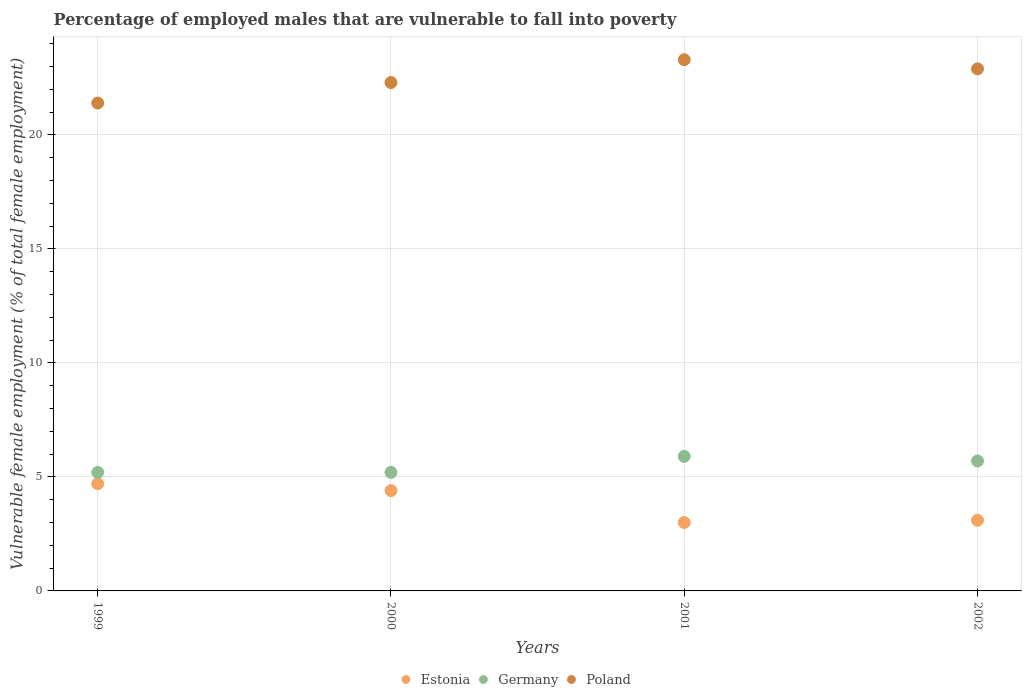What is the percentage of employed males who are vulnerable to fall into poverty in Poland in 2001?
Give a very brief answer. 23.3. Across all years, what is the maximum percentage of employed males who are vulnerable to fall into poverty in Germany?
Your answer should be very brief. 5.9. Across all years, what is the minimum percentage of employed males who are vulnerable to fall into poverty in Estonia?
Make the answer very short. 3. In which year was the percentage of employed males who are vulnerable to fall into poverty in Poland minimum?
Keep it short and to the point. 1999. What is the total percentage of employed males who are vulnerable to fall into poverty in Germany in the graph?
Provide a succinct answer. 22. What is the difference between the percentage of employed males who are vulnerable to fall into poverty in Germany in 1999 and that in 2000?
Make the answer very short. 0. What is the difference between the percentage of employed males who are vulnerable to fall into poverty in Estonia in 2002 and the percentage of employed males who are vulnerable to fall into poverty in Germany in 2001?
Offer a very short reply. -2.8. What is the average percentage of employed males who are vulnerable to fall into poverty in Poland per year?
Offer a very short reply. 22.47. In the year 2001, what is the difference between the percentage of employed males who are vulnerable to fall into poverty in Estonia and percentage of employed males who are vulnerable to fall into poverty in Germany?
Give a very brief answer. -2.9. In how many years, is the percentage of employed males who are vulnerable to fall into poverty in Estonia greater than 12 %?
Your response must be concise. 0. What is the ratio of the percentage of employed males who are vulnerable to fall into poverty in Estonia in 2000 to that in 2001?
Your answer should be very brief. 1.47. Is the percentage of employed males who are vulnerable to fall into poverty in Estonia in 2000 less than that in 2002?
Your response must be concise. No. What is the difference between the highest and the second highest percentage of employed males who are vulnerable to fall into poverty in Germany?
Offer a terse response. 0.2. What is the difference between the highest and the lowest percentage of employed males who are vulnerable to fall into poverty in Poland?
Ensure brevity in your answer.  1.9. In how many years, is the percentage of employed males who are vulnerable to fall into poverty in Poland greater than the average percentage of employed males who are vulnerable to fall into poverty in Poland taken over all years?
Ensure brevity in your answer.  2. Does the percentage of employed males who are vulnerable to fall into poverty in Poland monotonically increase over the years?
Provide a short and direct response. No. How many dotlines are there?
Your answer should be compact. 3. How many years are there in the graph?
Make the answer very short. 4. Are the values on the major ticks of Y-axis written in scientific E-notation?
Ensure brevity in your answer.  No. Does the graph contain any zero values?
Offer a very short reply. No. Does the graph contain grids?
Your answer should be very brief. Yes. Where does the legend appear in the graph?
Your answer should be very brief. Bottom center. How many legend labels are there?
Your answer should be very brief. 3. How are the legend labels stacked?
Your response must be concise. Horizontal. What is the title of the graph?
Your answer should be compact. Percentage of employed males that are vulnerable to fall into poverty. Does "Serbia" appear as one of the legend labels in the graph?
Provide a succinct answer. No. What is the label or title of the X-axis?
Make the answer very short. Years. What is the label or title of the Y-axis?
Offer a terse response. Vulnerable female employment (% of total female employment). What is the Vulnerable female employment (% of total female employment) in Estonia in 1999?
Give a very brief answer. 4.7. What is the Vulnerable female employment (% of total female employment) of Germany in 1999?
Ensure brevity in your answer.  5.2. What is the Vulnerable female employment (% of total female employment) in Poland in 1999?
Your answer should be very brief. 21.4. What is the Vulnerable female employment (% of total female employment) of Estonia in 2000?
Provide a succinct answer. 4.4. What is the Vulnerable female employment (% of total female employment) in Germany in 2000?
Provide a succinct answer. 5.2. What is the Vulnerable female employment (% of total female employment) in Poland in 2000?
Keep it short and to the point. 22.3. What is the Vulnerable female employment (% of total female employment) of Germany in 2001?
Provide a succinct answer. 5.9. What is the Vulnerable female employment (% of total female employment) of Poland in 2001?
Offer a very short reply. 23.3. What is the Vulnerable female employment (% of total female employment) of Estonia in 2002?
Offer a very short reply. 3.1. What is the Vulnerable female employment (% of total female employment) of Germany in 2002?
Give a very brief answer. 5.7. What is the Vulnerable female employment (% of total female employment) in Poland in 2002?
Offer a terse response. 22.9. Across all years, what is the maximum Vulnerable female employment (% of total female employment) of Estonia?
Provide a short and direct response. 4.7. Across all years, what is the maximum Vulnerable female employment (% of total female employment) of Germany?
Provide a succinct answer. 5.9. Across all years, what is the maximum Vulnerable female employment (% of total female employment) in Poland?
Provide a succinct answer. 23.3. Across all years, what is the minimum Vulnerable female employment (% of total female employment) of Germany?
Make the answer very short. 5.2. Across all years, what is the minimum Vulnerable female employment (% of total female employment) in Poland?
Ensure brevity in your answer.  21.4. What is the total Vulnerable female employment (% of total female employment) in Germany in the graph?
Your answer should be compact. 22. What is the total Vulnerable female employment (% of total female employment) of Poland in the graph?
Provide a short and direct response. 89.9. What is the difference between the Vulnerable female employment (% of total female employment) of Estonia in 1999 and that in 2000?
Provide a succinct answer. 0.3. What is the difference between the Vulnerable female employment (% of total female employment) of Germany in 1999 and that in 2000?
Your answer should be compact. 0. What is the difference between the Vulnerable female employment (% of total female employment) in Poland in 1999 and that in 2000?
Provide a succinct answer. -0.9. What is the difference between the Vulnerable female employment (% of total female employment) in Poland in 1999 and that in 2001?
Ensure brevity in your answer.  -1.9. What is the difference between the Vulnerable female employment (% of total female employment) in Poland in 1999 and that in 2002?
Keep it short and to the point. -1.5. What is the difference between the Vulnerable female employment (% of total female employment) in Estonia in 2000 and that in 2002?
Give a very brief answer. 1.3. What is the difference between the Vulnerable female employment (% of total female employment) in Estonia in 2001 and that in 2002?
Give a very brief answer. -0.1. What is the difference between the Vulnerable female employment (% of total female employment) of Germany in 2001 and that in 2002?
Your answer should be very brief. 0.2. What is the difference between the Vulnerable female employment (% of total female employment) of Poland in 2001 and that in 2002?
Offer a very short reply. 0.4. What is the difference between the Vulnerable female employment (% of total female employment) in Estonia in 1999 and the Vulnerable female employment (% of total female employment) in Poland in 2000?
Keep it short and to the point. -17.6. What is the difference between the Vulnerable female employment (% of total female employment) in Germany in 1999 and the Vulnerable female employment (% of total female employment) in Poland in 2000?
Your answer should be compact. -17.1. What is the difference between the Vulnerable female employment (% of total female employment) in Estonia in 1999 and the Vulnerable female employment (% of total female employment) in Poland in 2001?
Offer a very short reply. -18.6. What is the difference between the Vulnerable female employment (% of total female employment) of Germany in 1999 and the Vulnerable female employment (% of total female employment) of Poland in 2001?
Keep it short and to the point. -18.1. What is the difference between the Vulnerable female employment (% of total female employment) of Estonia in 1999 and the Vulnerable female employment (% of total female employment) of Poland in 2002?
Your response must be concise. -18.2. What is the difference between the Vulnerable female employment (% of total female employment) of Germany in 1999 and the Vulnerable female employment (% of total female employment) of Poland in 2002?
Give a very brief answer. -17.7. What is the difference between the Vulnerable female employment (% of total female employment) in Estonia in 2000 and the Vulnerable female employment (% of total female employment) in Germany in 2001?
Your answer should be compact. -1.5. What is the difference between the Vulnerable female employment (% of total female employment) in Estonia in 2000 and the Vulnerable female employment (% of total female employment) in Poland in 2001?
Your response must be concise. -18.9. What is the difference between the Vulnerable female employment (% of total female employment) in Germany in 2000 and the Vulnerable female employment (% of total female employment) in Poland in 2001?
Offer a terse response. -18.1. What is the difference between the Vulnerable female employment (% of total female employment) of Estonia in 2000 and the Vulnerable female employment (% of total female employment) of Germany in 2002?
Offer a very short reply. -1.3. What is the difference between the Vulnerable female employment (% of total female employment) of Estonia in 2000 and the Vulnerable female employment (% of total female employment) of Poland in 2002?
Your answer should be very brief. -18.5. What is the difference between the Vulnerable female employment (% of total female employment) of Germany in 2000 and the Vulnerable female employment (% of total female employment) of Poland in 2002?
Provide a short and direct response. -17.7. What is the difference between the Vulnerable female employment (% of total female employment) of Estonia in 2001 and the Vulnerable female employment (% of total female employment) of Poland in 2002?
Offer a terse response. -19.9. What is the average Vulnerable female employment (% of total female employment) of Estonia per year?
Make the answer very short. 3.8. What is the average Vulnerable female employment (% of total female employment) of Germany per year?
Your response must be concise. 5.5. What is the average Vulnerable female employment (% of total female employment) in Poland per year?
Your answer should be compact. 22.48. In the year 1999, what is the difference between the Vulnerable female employment (% of total female employment) of Estonia and Vulnerable female employment (% of total female employment) of Germany?
Ensure brevity in your answer.  -0.5. In the year 1999, what is the difference between the Vulnerable female employment (% of total female employment) of Estonia and Vulnerable female employment (% of total female employment) of Poland?
Ensure brevity in your answer.  -16.7. In the year 1999, what is the difference between the Vulnerable female employment (% of total female employment) in Germany and Vulnerable female employment (% of total female employment) in Poland?
Provide a succinct answer. -16.2. In the year 2000, what is the difference between the Vulnerable female employment (% of total female employment) in Estonia and Vulnerable female employment (% of total female employment) in Germany?
Your answer should be compact. -0.8. In the year 2000, what is the difference between the Vulnerable female employment (% of total female employment) in Estonia and Vulnerable female employment (% of total female employment) in Poland?
Provide a succinct answer. -17.9. In the year 2000, what is the difference between the Vulnerable female employment (% of total female employment) of Germany and Vulnerable female employment (% of total female employment) of Poland?
Provide a succinct answer. -17.1. In the year 2001, what is the difference between the Vulnerable female employment (% of total female employment) of Estonia and Vulnerable female employment (% of total female employment) of Poland?
Give a very brief answer. -20.3. In the year 2001, what is the difference between the Vulnerable female employment (% of total female employment) of Germany and Vulnerable female employment (% of total female employment) of Poland?
Provide a short and direct response. -17.4. In the year 2002, what is the difference between the Vulnerable female employment (% of total female employment) of Estonia and Vulnerable female employment (% of total female employment) of Poland?
Provide a short and direct response. -19.8. In the year 2002, what is the difference between the Vulnerable female employment (% of total female employment) in Germany and Vulnerable female employment (% of total female employment) in Poland?
Your response must be concise. -17.2. What is the ratio of the Vulnerable female employment (% of total female employment) of Estonia in 1999 to that in 2000?
Offer a terse response. 1.07. What is the ratio of the Vulnerable female employment (% of total female employment) of Germany in 1999 to that in 2000?
Provide a short and direct response. 1. What is the ratio of the Vulnerable female employment (% of total female employment) in Poland in 1999 to that in 2000?
Provide a short and direct response. 0.96. What is the ratio of the Vulnerable female employment (% of total female employment) of Estonia in 1999 to that in 2001?
Offer a very short reply. 1.57. What is the ratio of the Vulnerable female employment (% of total female employment) in Germany in 1999 to that in 2001?
Provide a succinct answer. 0.88. What is the ratio of the Vulnerable female employment (% of total female employment) of Poland in 1999 to that in 2001?
Offer a very short reply. 0.92. What is the ratio of the Vulnerable female employment (% of total female employment) of Estonia in 1999 to that in 2002?
Keep it short and to the point. 1.52. What is the ratio of the Vulnerable female employment (% of total female employment) in Germany in 1999 to that in 2002?
Offer a terse response. 0.91. What is the ratio of the Vulnerable female employment (% of total female employment) of Poland in 1999 to that in 2002?
Offer a very short reply. 0.93. What is the ratio of the Vulnerable female employment (% of total female employment) in Estonia in 2000 to that in 2001?
Provide a short and direct response. 1.47. What is the ratio of the Vulnerable female employment (% of total female employment) in Germany in 2000 to that in 2001?
Give a very brief answer. 0.88. What is the ratio of the Vulnerable female employment (% of total female employment) in Poland in 2000 to that in 2001?
Provide a succinct answer. 0.96. What is the ratio of the Vulnerable female employment (% of total female employment) of Estonia in 2000 to that in 2002?
Ensure brevity in your answer.  1.42. What is the ratio of the Vulnerable female employment (% of total female employment) of Germany in 2000 to that in 2002?
Ensure brevity in your answer.  0.91. What is the ratio of the Vulnerable female employment (% of total female employment) in Poland in 2000 to that in 2002?
Your answer should be very brief. 0.97. What is the ratio of the Vulnerable female employment (% of total female employment) of Germany in 2001 to that in 2002?
Your response must be concise. 1.04. What is the ratio of the Vulnerable female employment (% of total female employment) of Poland in 2001 to that in 2002?
Your answer should be compact. 1.02. What is the difference between the highest and the second highest Vulnerable female employment (% of total female employment) of Poland?
Provide a succinct answer. 0.4. What is the difference between the highest and the lowest Vulnerable female employment (% of total female employment) of Poland?
Offer a terse response. 1.9. 